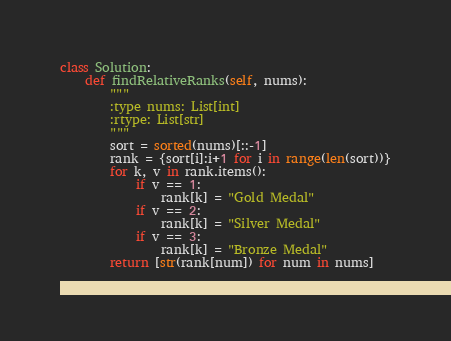<code> <loc_0><loc_0><loc_500><loc_500><_Python_>class Solution:
    def findRelativeRanks(self, nums):
        """
        :type nums: List[int]
        :rtype: List[str]
        """
        sort = sorted(nums)[::-1]
        rank = {sort[i]:i+1 for i in range(len(sort))}
        for k, v in rank.items():
            if v == 1:
                rank[k] = "Gold Medal"
            if v == 2:
                rank[k] = "Silver Medal"
            if v == 3:
                rank[k] = "Bronze Medal"
        return [str(rank[num]) for num in nums]
        
</code> 